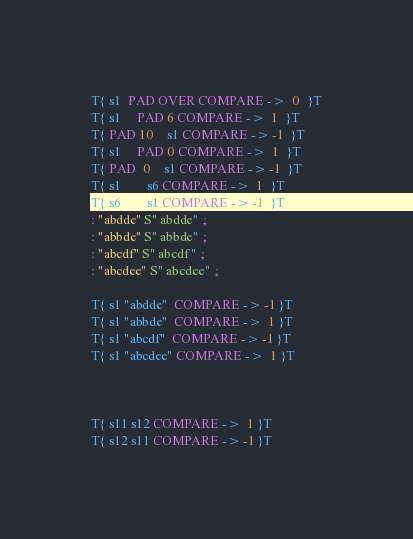<code> <loc_0><loc_0><loc_500><loc_500><_Forth_>T{ s1  PAD OVER COMPARE ->  0  }T
T{ s1     PAD 6 COMPARE ->  1  }T
T{ PAD 10    s1 COMPARE -> -1  }T
T{ s1     PAD 0 COMPARE ->  1  }T
T{ PAD  0    s1 COMPARE -> -1  }T
T{ s1        s6 COMPARE ->  1  }T
T{ s6        s1 COMPARE -> -1  }T
: "abdde" S" abdde" ;
: "abbde" S" abbde" ;
: "abcdf" S" abcdf" ;
: "abcdee" S" abcdee" ;

T{ s1 "abdde"  COMPARE -> -1 }T
T{ s1 "abbde"  COMPARE ->  1 }T
T{ s1 "abcdf"  COMPARE -> -1 }T
T{ s1 "abcdee" COMPARE ->  1 }T



T{ s11 s12 COMPARE ->  1 }T
T{ s12 s11 COMPARE -> -1 }T</code> 